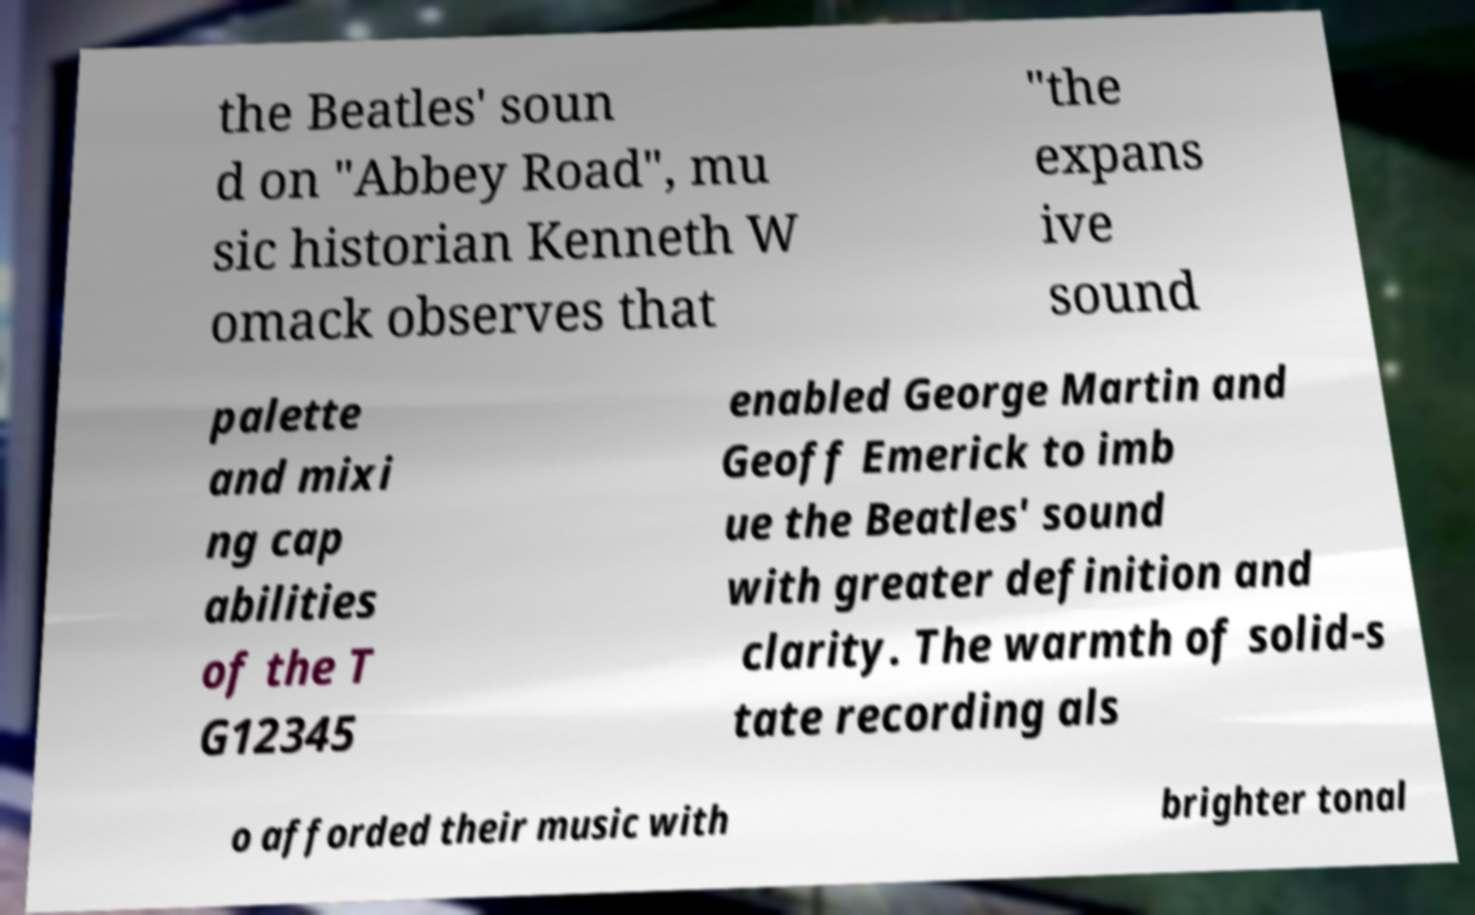I need the written content from this picture converted into text. Can you do that? the Beatles' soun d on "Abbey Road", mu sic historian Kenneth W omack observes that "the expans ive sound palette and mixi ng cap abilities of the T G12345 enabled George Martin and Geoff Emerick to imb ue the Beatles' sound with greater definition and clarity. The warmth of solid-s tate recording als o afforded their music with brighter tonal 